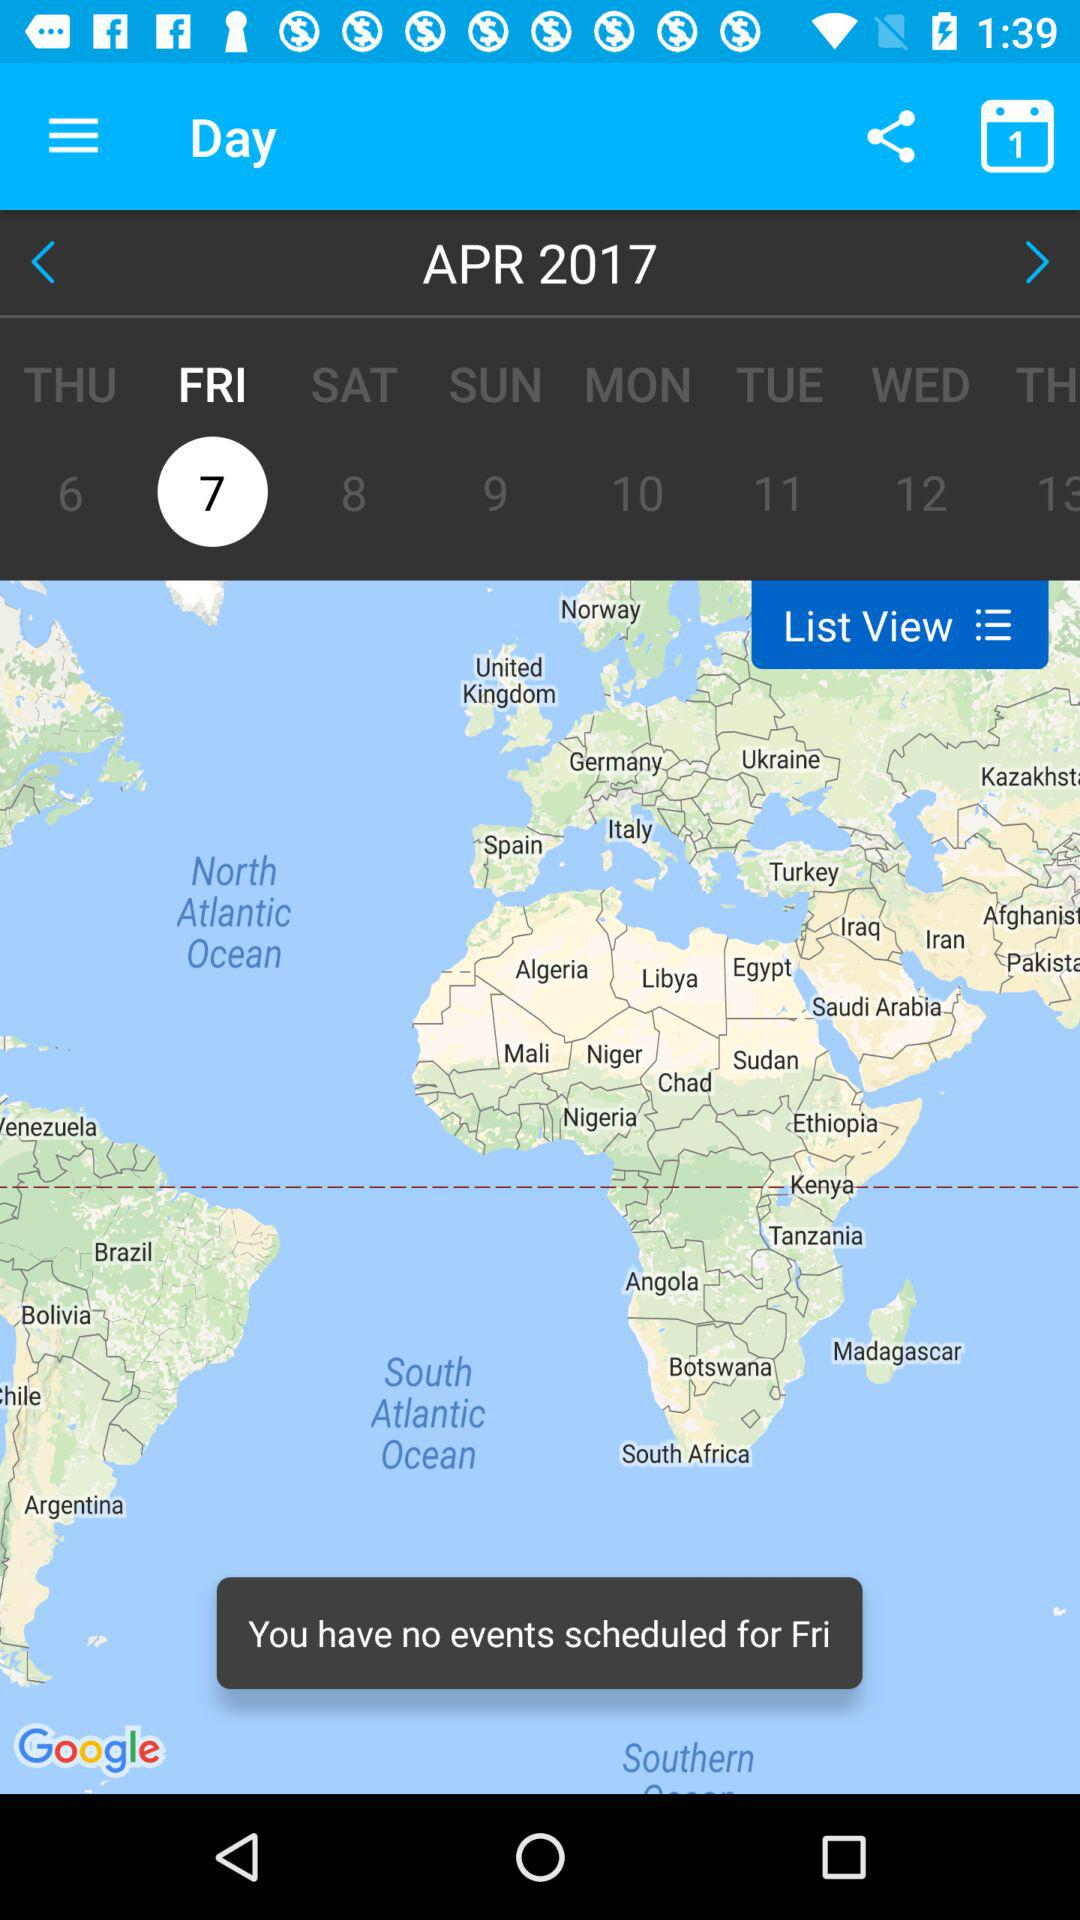What is the highlighted date? The highlighted date is Friday, April 7, 2017. 